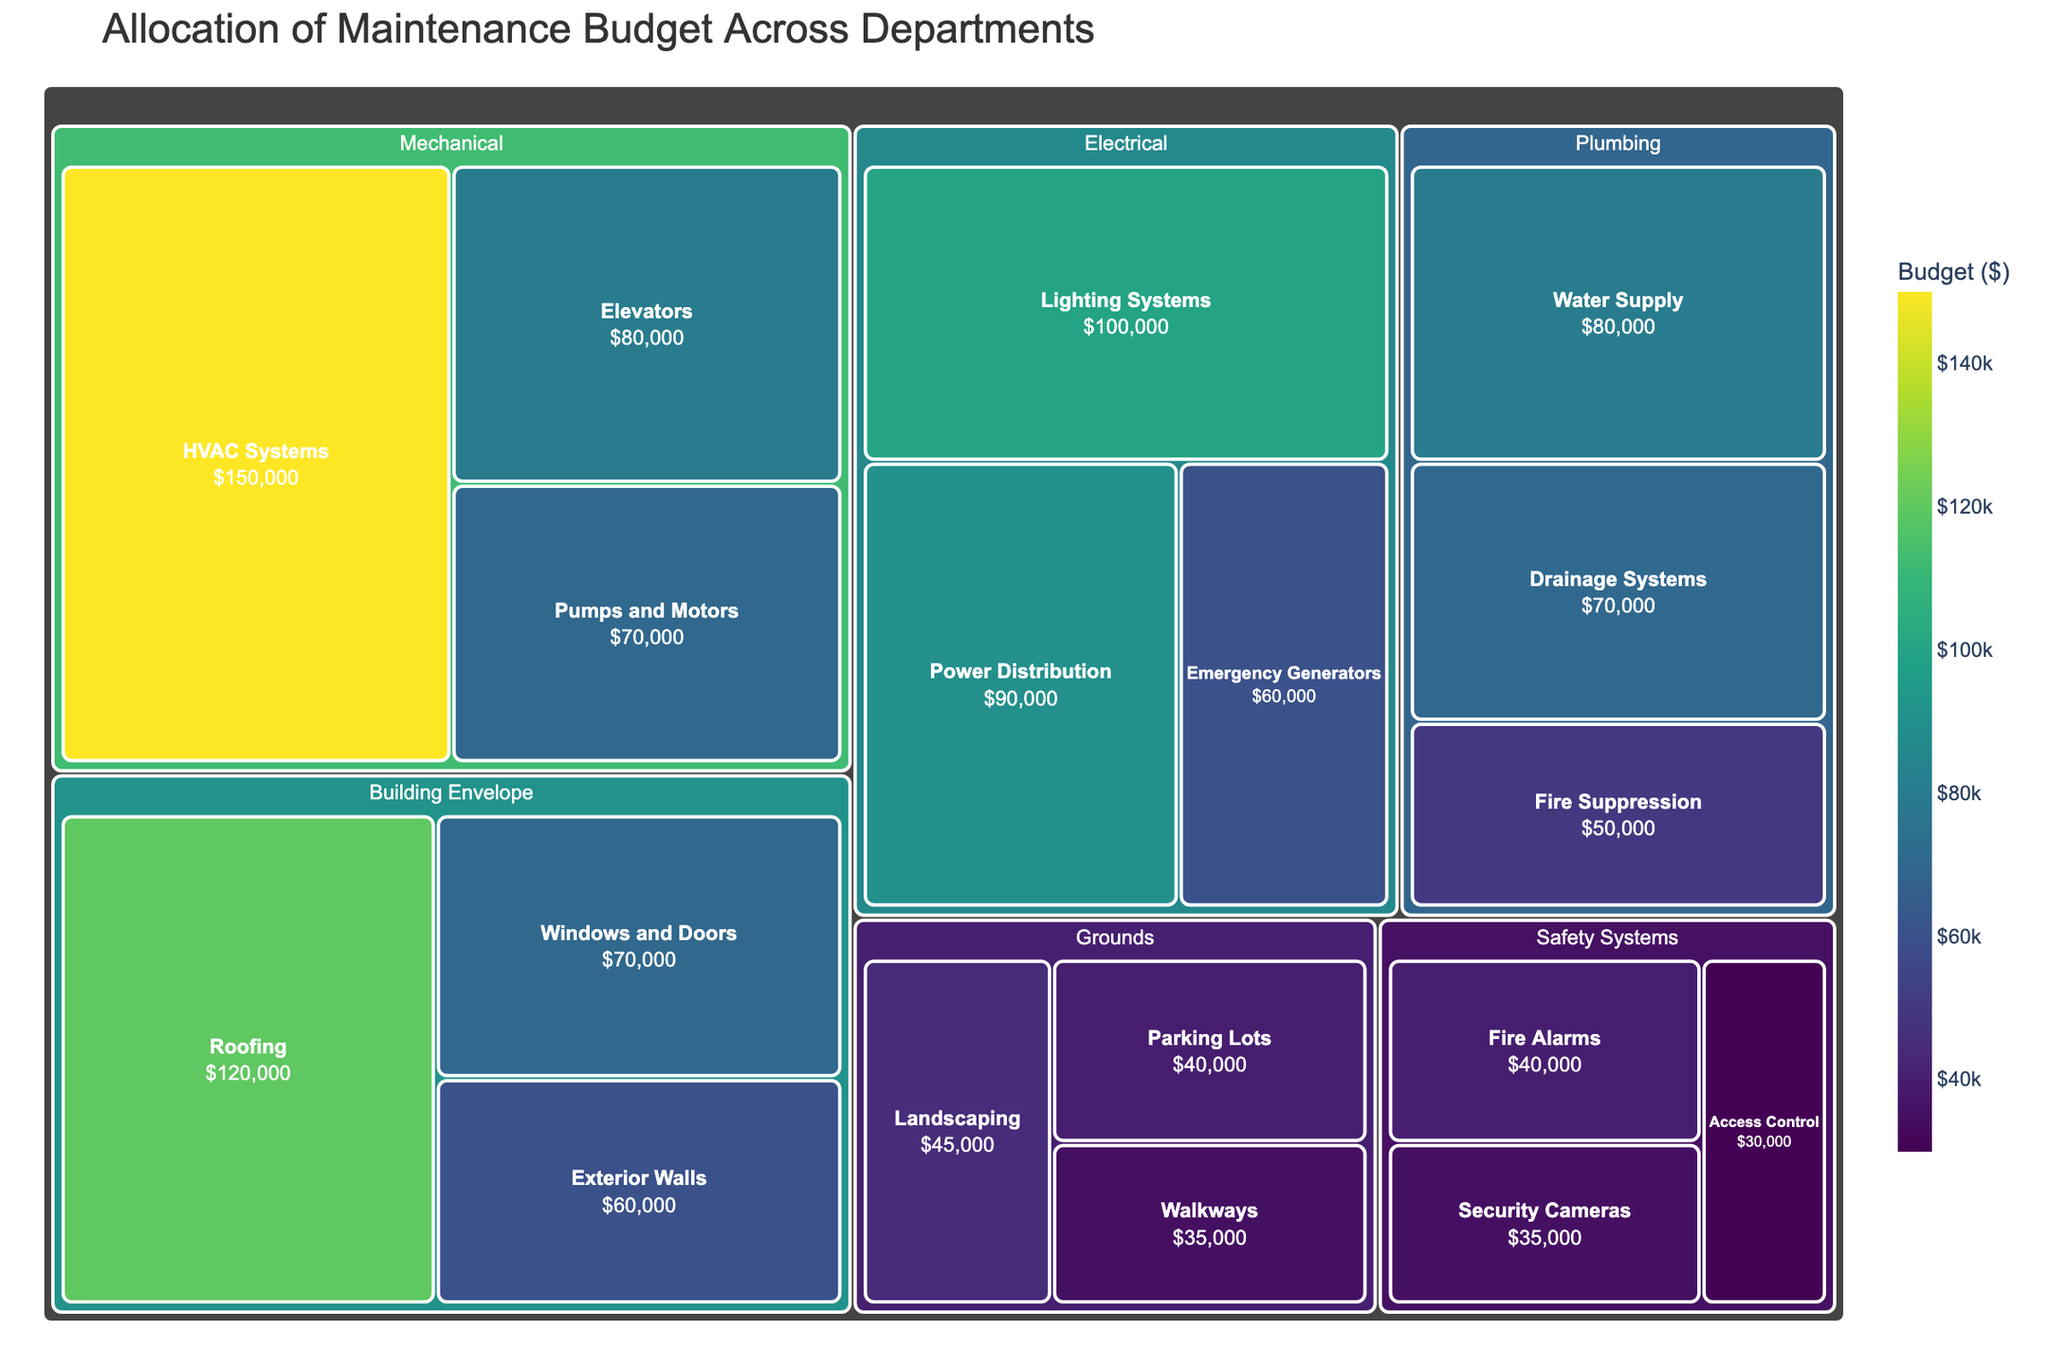which department has the largest total budget? Look for the department tiles with the largest size. The Mechanical department stands out as the largest tile.
Answer: Mechanical What is the budget allocated to HVAC Systems under the Mechanical department? The Mechanical department is divided into categories, and HVAC Systems is one of them. The budget allocated here is stated directly on the tile for HVAC Systems.
Answer: $150,000 Compare the budget allocation for Roofing and Windows and Doors in the Building Envelope department. Which is higher, and by how much? Identify both tiles under the Building Envelope department. Roofing has a budget of $120,000, and Windows and Doors have $70,000. Subtract the budget of Windows and Doors from Roofing.
Answer: Roofing by $50,000 Which category under Electrical has the least budget allocation? Look under the Electrical department and identify the smallest tile among Lighting Systems, Power Distribution, and Emergency Generators. Emergency Generators are labeled with the lowest budget.
Answer: Emergency Generators What is the combined budget for all categories within the Plumbing department? Sum the budgets for Water Supply ($80,000), Drainage Systems ($70,000), and Fire Suppression ($50,000). The sum is 80000 + 70000 + 50000.
Answer: $200,000 How much more budget is allocated to Landscaping than Walkways in the Grounds department? Compare the budgets for Landscaping ($45,000) and Walkways ($35,000). Subtract the budget for Walkways from Landscaping.
Answer: $10,000 Which department has the least total budget allocation? Look for the smallest department tile based on size. The Safety Systems department appears smaller than the others.
Answer: Safety Systems What is the average budget allocated per category within the Grounds department? Sum the budgets for all categories under Grounds (Landscaping: $45,000, Parking Lots: $40,000, Walkways: $35,000) and divide by the number of categories. (45000 + 40000 + 35000) / 3.
Answer: $40,000 